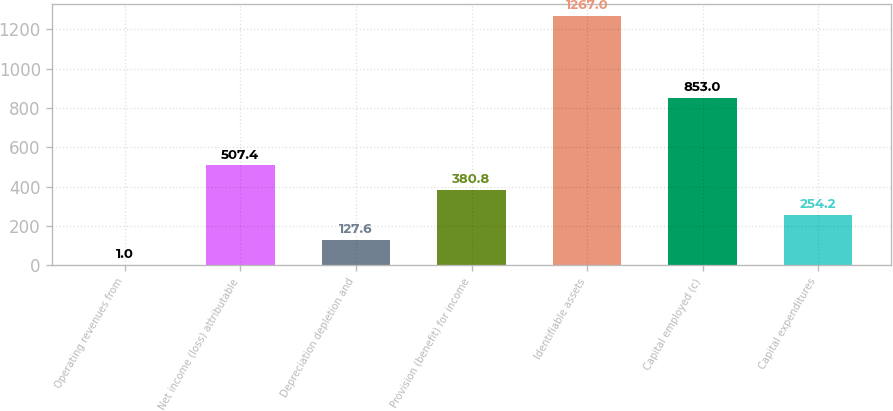Convert chart to OTSL. <chart><loc_0><loc_0><loc_500><loc_500><bar_chart><fcel>Operating revenues from<fcel>Net income (loss) attributable<fcel>Depreciation depletion and<fcel>Provision (benefit) for income<fcel>Identifiable assets<fcel>Capital employed (c)<fcel>Capital expenditures<nl><fcel>1<fcel>507.4<fcel>127.6<fcel>380.8<fcel>1267<fcel>853<fcel>254.2<nl></chart> 